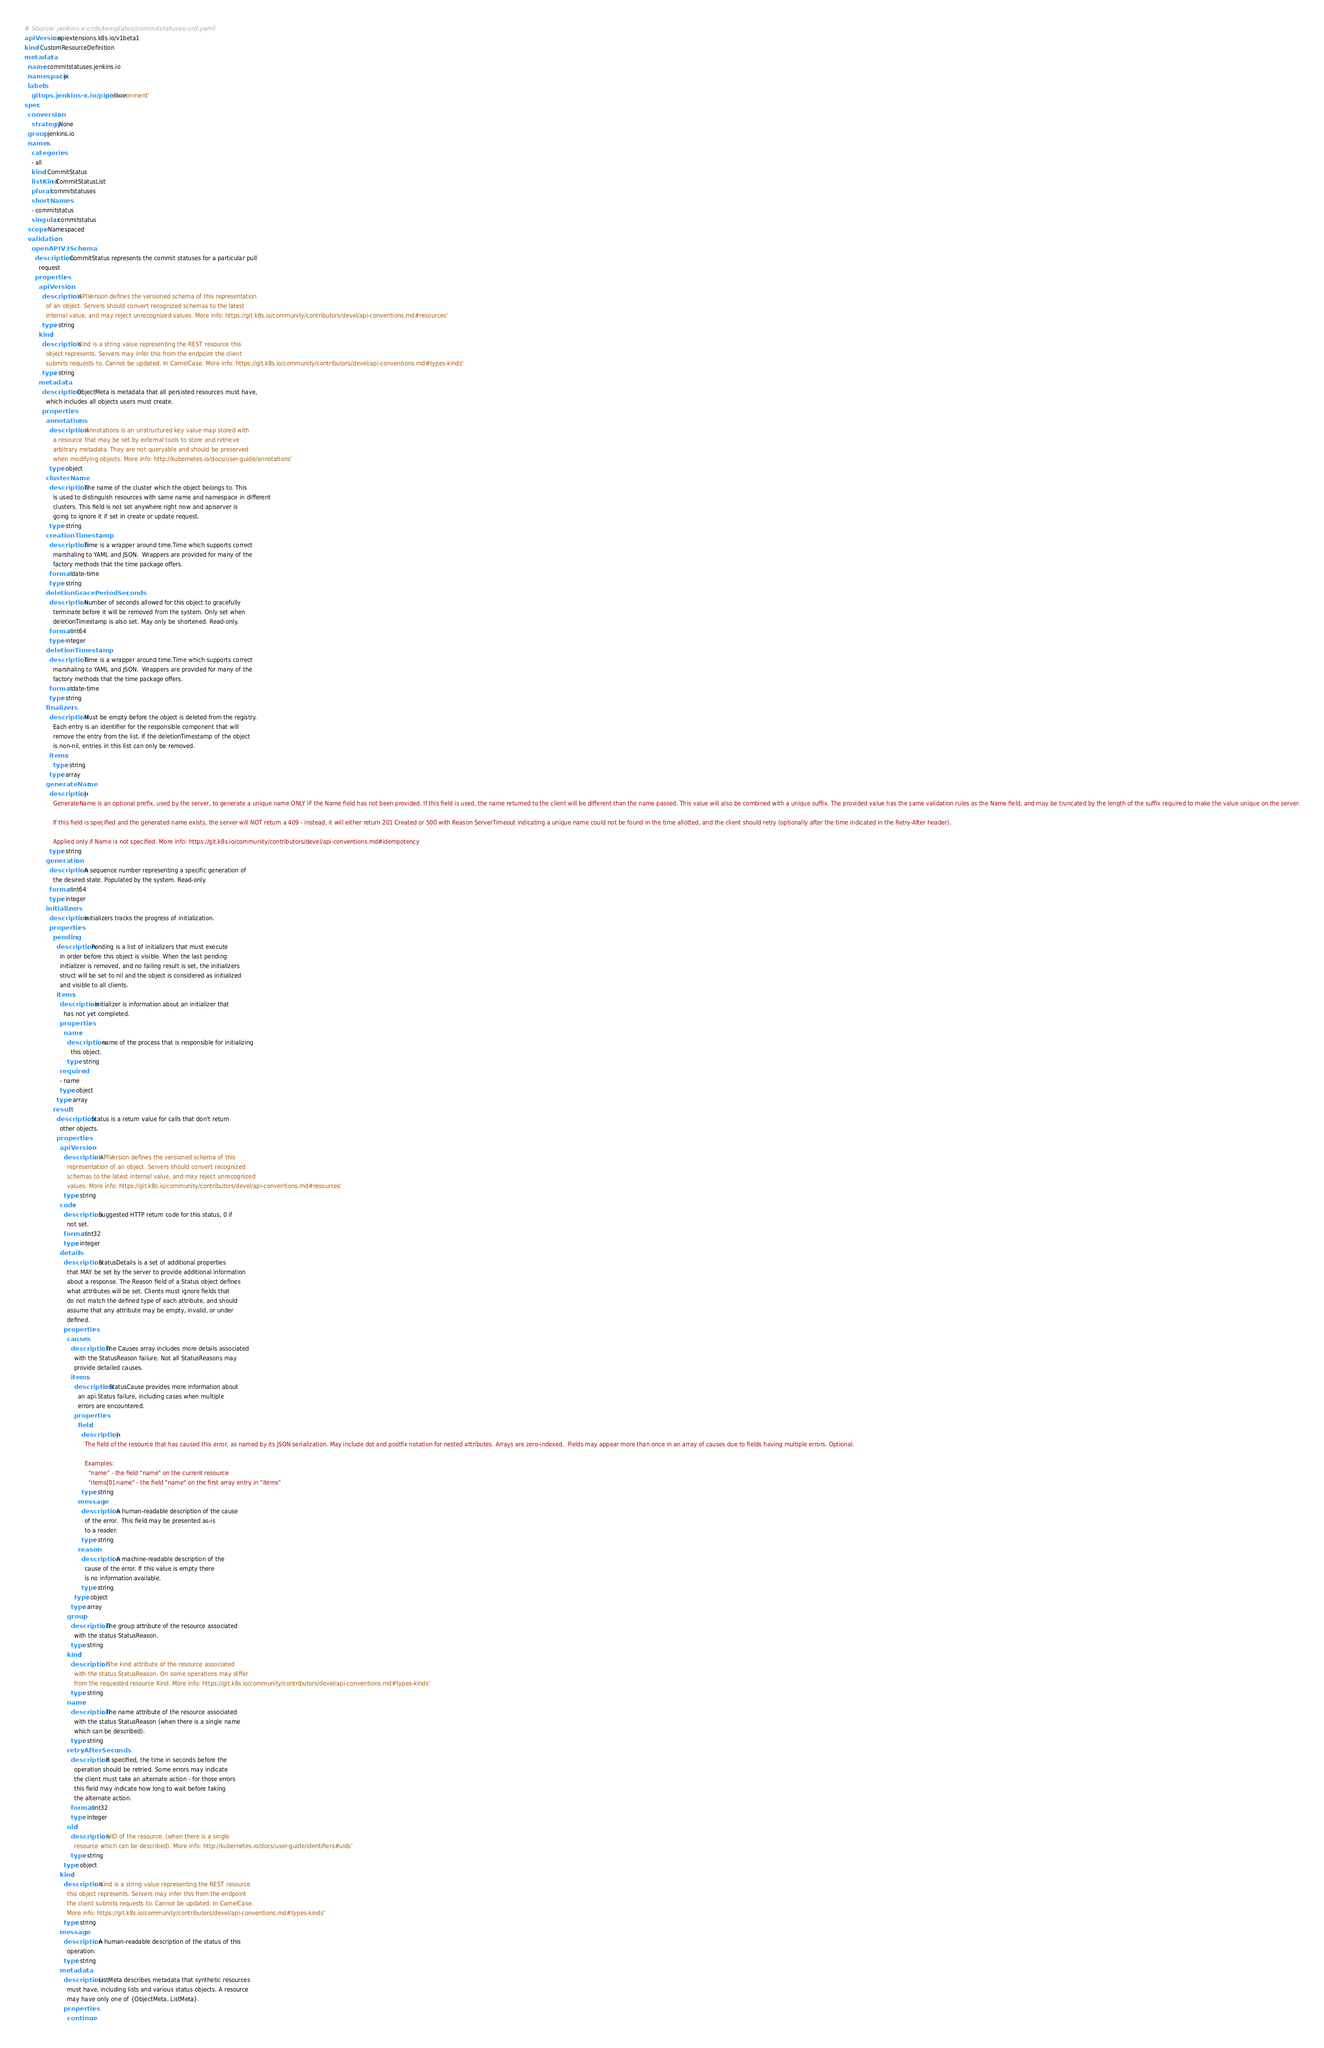<code> <loc_0><loc_0><loc_500><loc_500><_YAML_># Source: jenkins-x-crds/templates/commitstatuses-crd.yaml
apiVersion: apiextensions.k8s.io/v1beta1
kind: CustomResourceDefinition
metadata:
  name: commitstatuses.jenkins.io
  namespace: jx
  labels:
    gitops.jenkins-x.io/pipeline: 'environment'
spec:
  conversion:
    strategy: None
  group: jenkins.io
  names:
    categories:
    - all
    kind: CommitStatus
    listKind: CommitStatusList
    plural: commitstatuses
    shortNames:
    - commitstatus
    singular: commitstatus
  scope: Namespaced
  validation:
    openAPIV3Schema:
      description: CommitStatus represents the commit statuses for a particular pull
        request
      properties:
        apiVersion:
          description: 'APIVersion defines the versioned schema of this representation
            of an object. Servers should convert recognized schemas to the latest
            internal value, and may reject unrecognized values. More info: https://git.k8s.io/community/contributors/devel/api-conventions.md#resources'
          type: string
        kind:
          description: 'Kind is a string value representing the REST resource this
            object represents. Servers may infer this from the endpoint the client
            submits requests to. Cannot be updated. In CamelCase. More info: https://git.k8s.io/community/contributors/devel/api-conventions.md#types-kinds'
          type: string
        metadata:
          description: ObjectMeta is metadata that all persisted resources must have,
            which includes all objects users must create.
          properties:
            annotations:
              description: 'Annotations is an unstructured key value map stored with
                a resource that may be set by external tools to store and retrieve
                arbitrary metadata. They are not queryable and should be preserved
                when modifying objects. More info: http://kubernetes.io/docs/user-guide/annotations'
              type: object
            clusterName:
              description: The name of the cluster which the object belongs to. This
                is used to distinguish resources with same name and namespace in different
                clusters. This field is not set anywhere right now and apiserver is
                going to ignore it if set in create or update request.
              type: string
            creationTimestamp:
              description: Time is a wrapper around time.Time which supports correct
                marshaling to YAML and JSON.  Wrappers are provided for many of the
                factory methods that the time package offers.
              format: date-time
              type: string
            deletionGracePeriodSeconds:
              description: Number of seconds allowed for this object to gracefully
                terminate before it will be removed from the system. Only set when
                deletionTimestamp is also set. May only be shortened. Read-only.
              format: int64
              type: integer
            deletionTimestamp:
              description: Time is a wrapper around time.Time which supports correct
                marshaling to YAML and JSON.  Wrappers are provided for many of the
                factory methods that the time package offers.
              format: date-time
              type: string
            finalizers:
              description: Must be empty before the object is deleted from the registry.
                Each entry is an identifier for the responsible component that will
                remove the entry from the list. If the deletionTimestamp of the object
                is non-nil, entries in this list can only be removed.
              items:
                type: string
              type: array
            generateName:
              description: |-
                GenerateName is an optional prefix, used by the server, to generate a unique name ONLY IF the Name field has not been provided. If this field is used, the name returned to the client will be different than the name passed. This value will also be combined with a unique suffix. The provided value has the same validation rules as the Name field, and may be truncated by the length of the suffix required to make the value unique on the server.

                If this field is specified and the generated name exists, the server will NOT return a 409 - instead, it will either return 201 Created or 500 with Reason ServerTimeout indicating a unique name could not be found in the time allotted, and the client should retry (optionally after the time indicated in the Retry-After header).

                Applied only if Name is not specified. More info: https://git.k8s.io/community/contributors/devel/api-conventions.md#idempotency
              type: string
            generation:
              description: A sequence number representing a specific generation of
                the desired state. Populated by the system. Read-only.
              format: int64
              type: integer
            initializers:
              description: Initializers tracks the progress of initialization.
              properties:
                pending:
                  description: Pending is a list of initializers that must execute
                    in order before this object is visible. When the last pending
                    initializer is removed, and no failing result is set, the initializers
                    struct will be set to nil and the object is considered as initialized
                    and visible to all clients.
                  items:
                    description: Initializer is information about an initializer that
                      has not yet completed.
                    properties:
                      name:
                        description: name of the process that is responsible for initializing
                          this object.
                        type: string
                    required:
                    - name
                    type: object
                  type: array
                result:
                  description: Status is a return value for calls that don't return
                    other objects.
                  properties:
                    apiVersion:
                      description: 'APIVersion defines the versioned schema of this
                        representation of an object. Servers should convert recognized
                        schemas to the latest internal value, and may reject unrecognized
                        values. More info: https://git.k8s.io/community/contributors/devel/api-conventions.md#resources'
                      type: string
                    code:
                      description: Suggested HTTP return code for this status, 0 if
                        not set.
                      format: int32
                      type: integer
                    details:
                      description: StatusDetails is a set of additional properties
                        that MAY be set by the server to provide additional information
                        about a response. The Reason field of a Status object defines
                        what attributes will be set. Clients must ignore fields that
                        do not match the defined type of each attribute, and should
                        assume that any attribute may be empty, invalid, or under
                        defined.
                      properties:
                        causes:
                          description: The Causes array includes more details associated
                            with the StatusReason failure. Not all StatusReasons may
                            provide detailed causes.
                          items:
                            description: StatusCause provides more information about
                              an api.Status failure, including cases when multiple
                              errors are encountered.
                            properties:
                              field:
                                description: |-
                                  The field of the resource that has caused this error, as named by its JSON serialization. May include dot and postfix notation for nested attributes. Arrays are zero-indexed.  Fields may appear more than once in an array of causes due to fields having multiple errors. Optional.

                                  Examples:
                                    "name" - the field "name" on the current resource
                                    "items[0].name" - the field "name" on the first array entry in "items"
                                type: string
                              message:
                                description: A human-readable description of the cause
                                  of the error.  This field may be presented as-is
                                  to a reader.
                                type: string
                              reason:
                                description: A machine-readable description of the
                                  cause of the error. If this value is empty there
                                  is no information available.
                                type: string
                            type: object
                          type: array
                        group:
                          description: The group attribute of the resource associated
                            with the status StatusReason.
                          type: string
                        kind:
                          description: 'The kind attribute of the resource associated
                            with the status StatusReason. On some operations may differ
                            from the requested resource Kind. More info: https://git.k8s.io/community/contributors/devel/api-conventions.md#types-kinds'
                          type: string
                        name:
                          description: The name attribute of the resource associated
                            with the status StatusReason (when there is a single name
                            which can be described).
                          type: string
                        retryAfterSeconds:
                          description: If specified, the time in seconds before the
                            operation should be retried. Some errors may indicate
                            the client must take an alternate action - for those errors
                            this field may indicate how long to wait before taking
                            the alternate action.
                          format: int32
                          type: integer
                        uid:
                          description: 'UID of the resource. (when there is a single
                            resource which can be described). More info: http://kubernetes.io/docs/user-guide/identifiers#uids'
                          type: string
                      type: object
                    kind:
                      description: 'Kind is a string value representing the REST resource
                        this object represents. Servers may infer this from the endpoint
                        the client submits requests to. Cannot be updated. In CamelCase.
                        More info: https://git.k8s.io/community/contributors/devel/api-conventions.md#types-kinds'
                      type: string
                    message:
                      description: A human-readable description of the status of this
                        operation.
                      type: string
                    metadata:
                      description: ListMeta describes metadata that synthetic resources
                        must have, including lists and various status objects. A resource
                        may have only one of {ObjectMeta, ListMeta}.
                      properties:
                        continue:</code> 